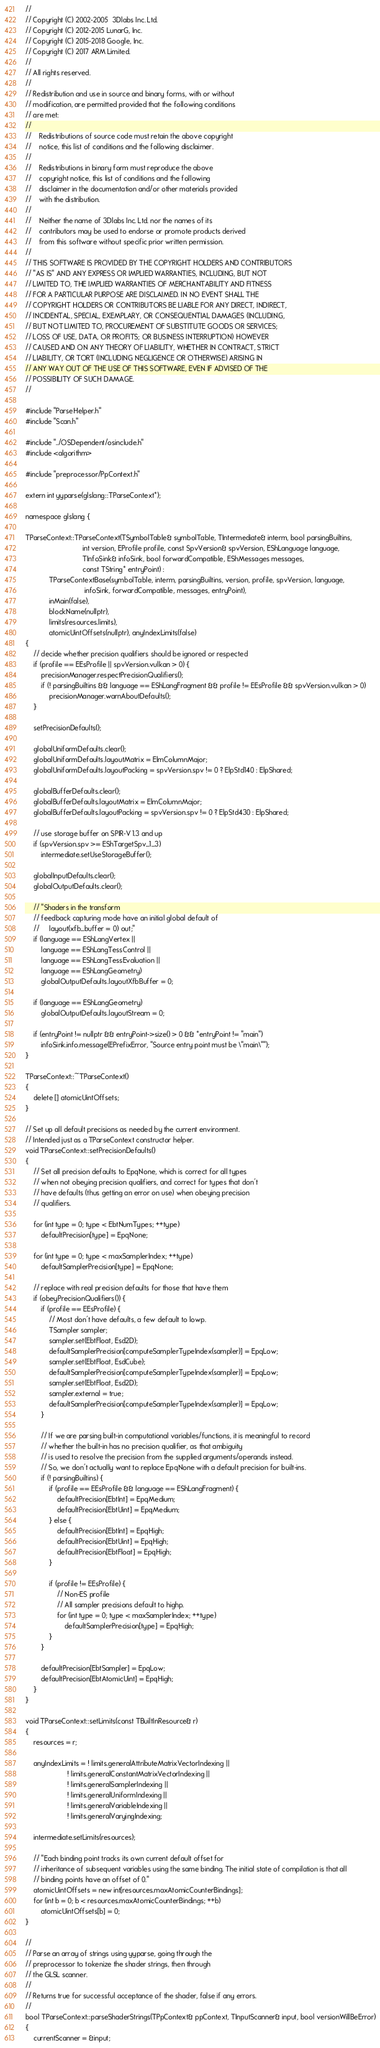<code> <loc_0><loc_0><loc_500><loc_500><_C++_>//
// Copyright (C) 2002-2005  3Dlabs Inc. Ltd.
// Copyright (C) 2012-2015 LunarG, Inc.
// Copyright (C) 2015-2018 Google, Inc.
// Copyright (C) 2017 ARM Limited.
//
// All rights reserved.
//
// Redistribution and use in source and binary forms, with or without
// modification, are permitted provided that the following conditions
// are met:
//
//    Redistributions of source code must retain the above copyright
//    notice, this list of conditions and the following disclaimer.
//
//    Redistributions in binary form must reproduce the above
//    copyright notice, this list of conditions and the following
//    disclaimer in the documentation and/or other materials provided
//    with the distribution.
//
//    Neither the name of 3Dlabs Inc. Ltd. nor the names of its
//    contributors may be used to endorse or promote products derived
//    from this software without specific prior written permission.
//
// THIS SOFTWARE IS PROVIDED BY THE COPYRIGHT HOLDERS AND CONTRIBUTORS
// "AS IS" AND ANY EXPRESS OR IMPLIED WARRANTIES, INCLUDING, BUT NOT
// LIMITED TO, THE IMPLIED WARRANTIES OF MERCHANTABILITY AND FITNESS
// FOR A PARTICULAR PURPOSE ARE DISCLAIMED. IN NO EVENT SHALL THE
// COPYRIGHT HOLDERS OR CONTRIBUTORS BE LIABLE FOR ANY DIRECT, INDIRECT,
// INCIDENTAL, SPECIAL, EXEMPLARY, OR CONSEQUENTIAL DAMAGES (INCLUDING,
// BUT NOT LIMITED TO, PROCUREMENT OF SUBSTITUTE GOODS OR SERVICES;
// LOSS OF USE, DATA, OR PROFITS; OR BUSINESS INTERRUPTION) HOWEVER
// CAUSED AND ON ANY THEORY OF LIABILITY, WHETHER IN CONTRACT, STRICT
// LIABILITY, OR TORT (INCLUDING NEGLIGENCE OR OTHERWISE) ARISING IN
// ANY WAY OUT OF THE USE OF THIS SOFTWARE, EVEN IF ADVISED OF THE
// POSSIBILITY OF SUCH DAMAGE.
//

#include "ParseHelper.h"
#include "Scan.h"

#include "../OSDependent/osinclude.h"
#include <algorithm>

#include "preprocessor/PpContext.h"

extern int yyparse(glslang::TParseContext*);

namespace glslang {

TParseContext::TParseContext(TSymbolTable& symbolTable, TIntermediate& interm, bool parsingBuiltins,
                             int version, EProfile profile, const SpvVersion& spvVersion, EShLanguage language,
                             TInfoSink& infoSink, bool forwardCompatible, EShMessages messages,
                             const TString* entryPoint) :
            TParseContextBase(symbolTable, interm, parsingBuiltins, version, profile, spvVersion, language,
                              infoSink, forwardCompatible, messages, entryPoint),
            inMain(false),
            blockName(nullptr),
            limits(resources.limits),
            atomicUintOffsets(nullptr), anyIndexLimits(false)
{
    // decide whether precision qualifiers should be ignored or respected
    if (profile == EEsProfile || spvVersion.vulkan > 0) {
        precisionManager.respectPrecisionQualifiers();
        if (! parsingBuiltins && language == EShLangFragment && profile != EEsProfile && spvVersion.vulkan > 0)
            precisionManager.warnAboutDefaults();
    }

    setPrecisionDefaults();

    globalUniformDefaults.clear();
    globalUniformDefaults.layoutMatrix = ElmColumnMajor;
    globalUniformDefaults.layoutPacking = spvVersion.spv != 0 ? ElpStd140 : ElpShared;

    globalBufferDefaults.clear();
    globalBufferDefaults.layoutMatrix = ElmColumnMajor;
    globalBufferDefaults.layoutPacking = spvVersion.spv != 0 ? ElpStd430 : ElpShared;

    // use storage buffer on SPIR-V 1.3 and up
    if (spvVersion.spv >= EShTargetSpv_1_3)
        intermediate.setUseStorageBuffer();

    globalInputDefaults.clear();
    globalOutputDefaults.clear();

    // "Shaders in the transform
    // feedback capturing mode have an initial global default of
    //     layout(xfb_buffer = 0) out;"
    if (language == EShLangVertex ||
        language == EShLangTessControl ||
        language == EShLangTessEvaluation ||
        language == EShLangGeometry)
        globalOutputDefaults.layoutXfbBuffer = 0;

    if (language == EShLangGeometry)
        globalOutputDefaults.layoutStream = 0;

    if (entryPoint != nullptr && entryPoint->size() > 0 && *entryPoint != "main")
        infoSink.info.message(EPrefixError, "Source entry point must be \"main\"");
}

TParseContext::~TParseContext()
{
    delete [] atomicUintOffsets;
}

// Set up all default precisions as needed by the current environment.
// Intended just as a TParseContext constructor helper.
void TParseContext::setPrecisionDefaults()
{
    // Set all precision defaults to EpqNone, which is correct for all types
    // when not obeying precision qualifiers, and correct for types that don't
    // have defaults (thus getting an error on use) when obeying precision
    // qualifiers.

    for (int type = 0; type < EbtNumTypes; ++type)
        defaultPrecision[type] = EpqNone;

    for (int type = 0; type < maxSamplerIndex; ++type)
        defaultSamplerPrecision[type] = EpqNone;

    // replace with real precision defaults for those that have them
    if (obeyPrecisionQualifiers()) {
        if (profile == EEsProfile) {
            // Most don't have defaults, a few default to lowp.
            TSampler sampler;
            sampler.set(EbtFloat, Esd2D);
            defaultSamplerPrecision[computeSamplerTypeIndex(sampler)] = EpqLow;
            sampler.set(EbtFloat, EsdCube);
            defaultSamplerPrecision[computeSamplerTypeIndex(sampler)] = EpqLow;
            sampler.set(EbtFloat, Esd2D);
            sampler.external = true;
            defaultSamplerPrecision[computeSamplerTypeIndex(sampler)] = EpqLow;
        }

        // If we are parsing built-in computational variables/functions, it is meaningful to record
        // whether the built-in has no precision qualifier, as that ambiguity
        // is used to resolve the precision from the supplied arguments/operands instead.
        // So, we don't actually want to replace EpqNone with a default precision for built-ins.
        if (! parsingBuiltins) {
            if (profile == EEsProfile && language == EShLangFragment) {
                defaultPrecision[EbtInt] = EpqMedium;
                defaultPrecision[EbtUint] = EpqMedium;
            } else {
                defaultPrecision[EbtInt] = EpqHigh;
                defaultPrecision[EbtUint] = EpqHigh;
                defaultPrecision[EbtFloat] = EpqHigh;
            }

            if (profile != EEsProfile) {
                // Non-ES profile
                // All sampler precisions default to highp.
                for (int type = 0; type < maxSamplerIndex; ++type)
                    defaultSamplerPrecision[type] = EpqHigh;
            }
        }

        defaultPrecision[EbtSampler] = EpqLow;
        defaultPrecision[EbtAtomicUint] = EpqHigh;
    }
}

void TParseContext::setLimits(const TBuiltInResource& r)
{
    resources = r;

    anyIndexLimits = ! limits.generalAttributeMatrixVectorIndexing ||
                     ! limits.generalConstantMatrixVectorIndexing ||
                     ! limits.generalSamplerIndexing ||
                     ! limits.generalUniformIndexing ||
                     ! limits.generalVariableIndexing ||
                     ! limits.generalVaryingIndexing;

    intermediate.setLimits(resources);

    // "Each binding point tracks its own current default offset for
    // inheritance of subsequent variables using the same binding. The initial state of compilation is that all
    // binding points have an offset of 0."
    atomicUintOffsets = new int[resources.maxAtomicCounterBindings];
    for (int b = 0; b < resources.maxAtomicCounterBindings; ++b)
        atomicUintOffsets[b] = 0;
}

//
// Parse an array of strings using yyparse, going through the
// preprocessor to tokenize the shader strings, then through
// the GLSL scanner.
//
// Returns true for successful acceptance of the shader, false if any errors.
//
bool TParseContext::parseShaderStrings(TPpContext& ppContext, TInputScanner& input, bool versionWillBeError)
{
    currentScanner = &input;</code> 